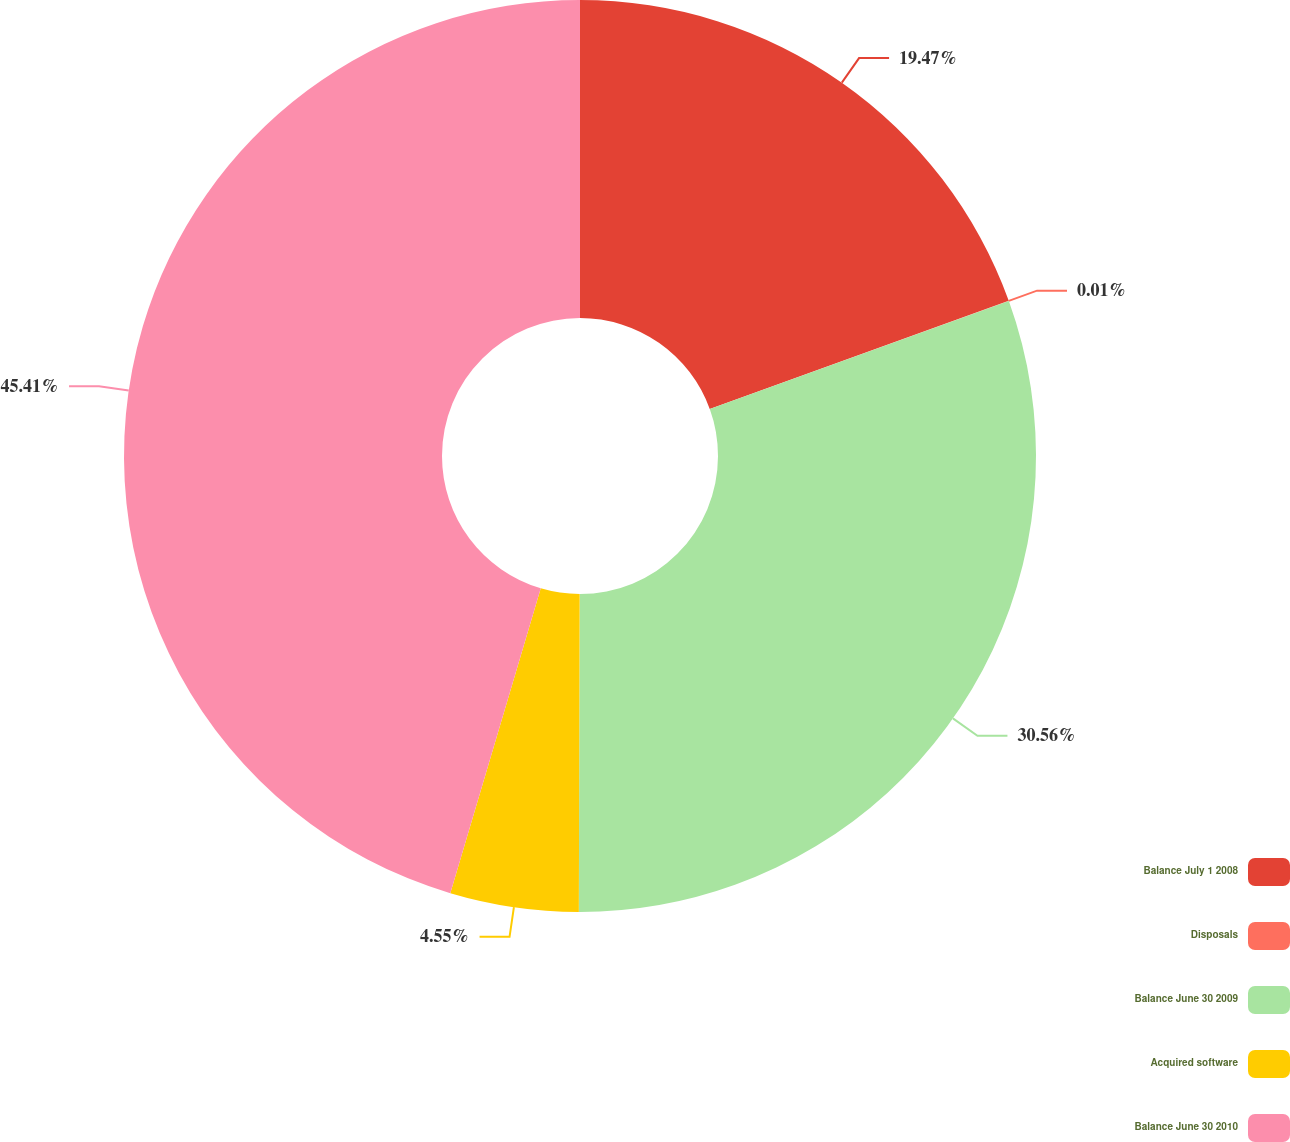Convert chart. <chart><loc_0><loc_0><loc_500><loc_500><pie_chart><fcel>Balance July 1 2008<fcel>Disposals<fcel>Balance June 30 2009<fcel>Acquired software<fcel>Balance June 30 2010<nl><fcel>19.47%<fcel>0.01%<fcel>30.56%<fcel>4.55%<fcel>45.41%<nl></chart> 